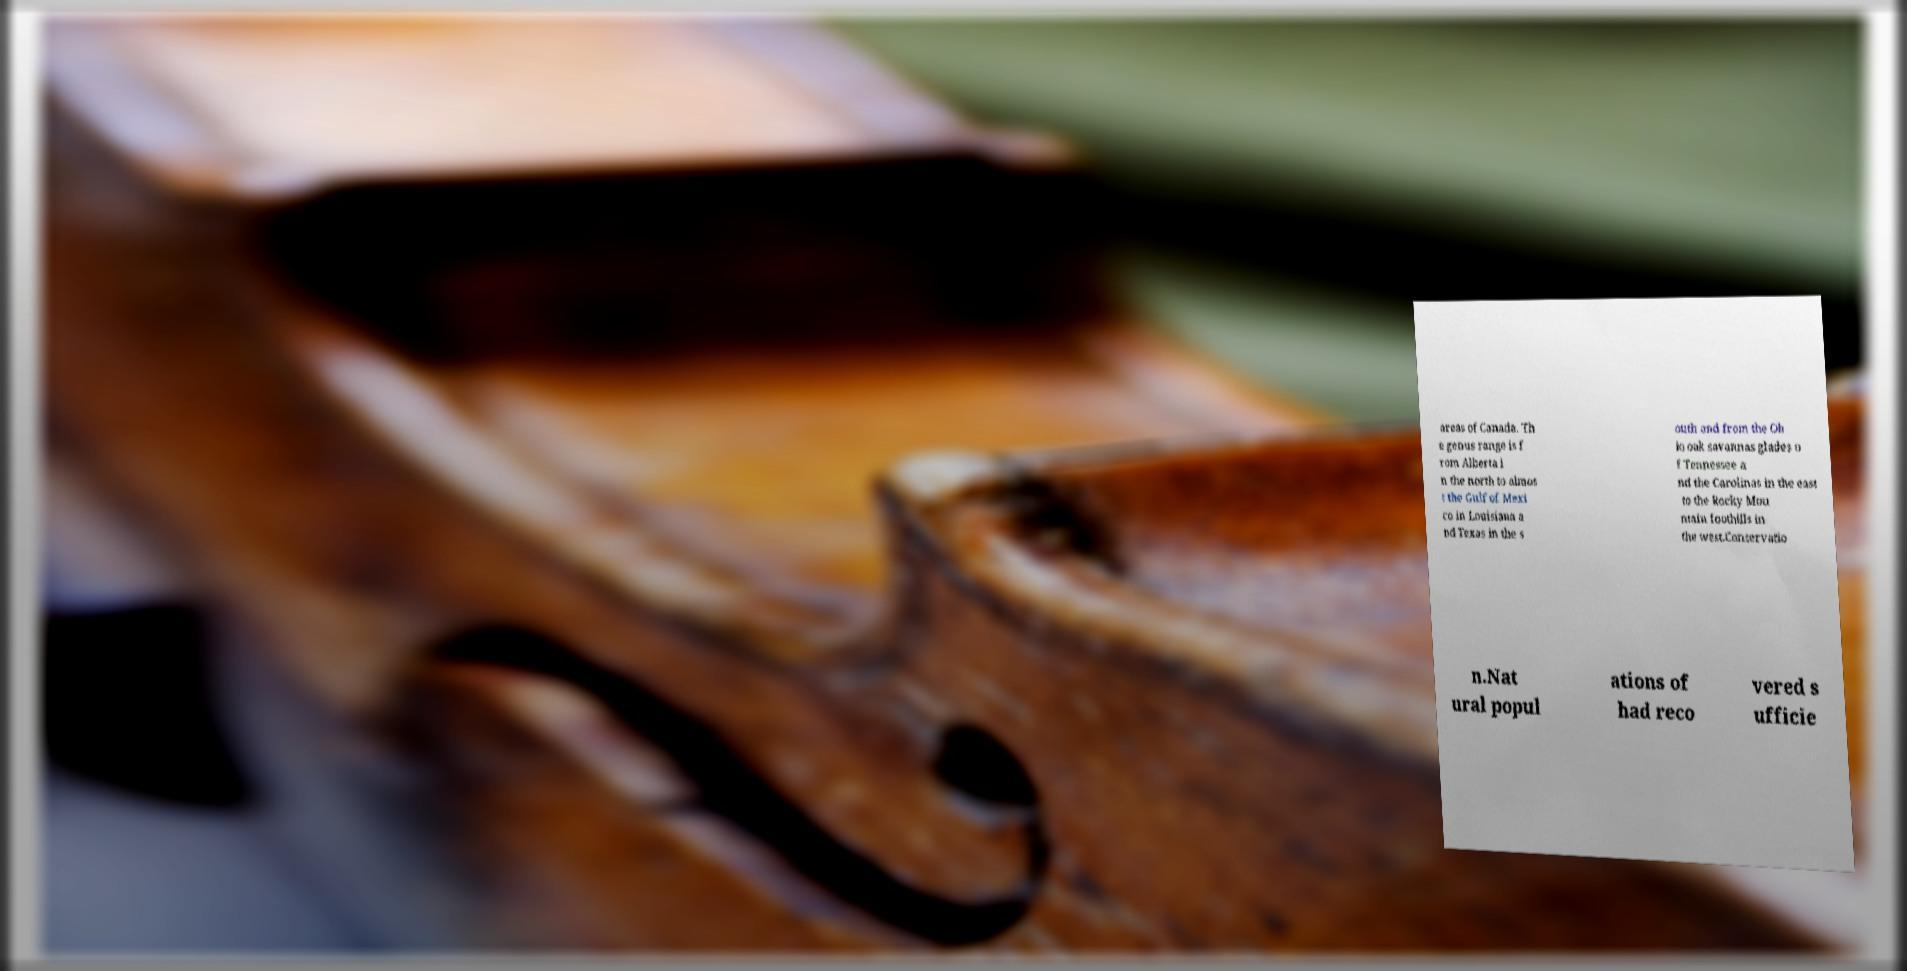Can you read and provide the text displayed in the image?This photo seems to have some interesting text. Can you extract and type it out for me? areas of Canada. Th e genus range is f rom Alberta i n the north to almos t the Gulf of Mexi co in Louisiana a nd Texas in the s outh and from the Oh io oak savannas glades o f Tennessee a nd the Carolinas in the east to the Rocky Mou ntain foothills in the west.Conservatio n.Nat ural popul ations of had reco vered s ufficie 